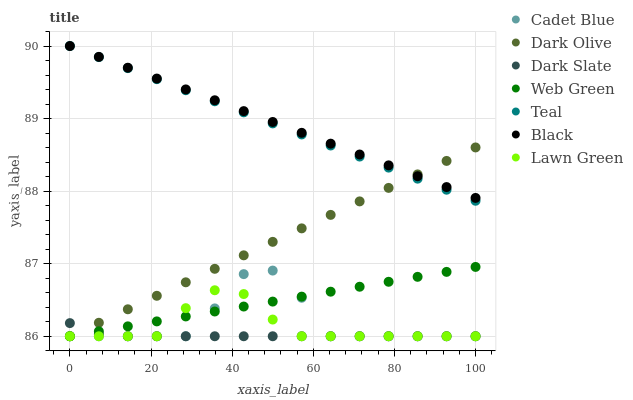Does Dark Slate have the minimum area under the curve?
Answer yes or no. Yes. Does Black have the maximum area under the curve?
Answer yes or no. Yes. Does Cadet Blue have the minimum area under the curve?
Answer yes or no. No. Does Cadet Blue have the maximum area under the curve?
Answer yes or no. No. Is Teal the smoothest?
Answer yes or no. Yes. Is Cadet Blue the roughest?
Answer yes or no. Yes. Is Dark Olive the smoothest?
Answer yes or no. No. Is Dark Olive the roughest?
Answer yes or no. No. Does Lawn Green have the lowest value?
Answer yes or no. Yes. Does Black have the lowest value?
Answer yes or no. No. Does Teal have the highest value?
Answer yes or no. Yes. Does Cadet Blue have the highest value?
Answer yes or no. No. Is Cadet Blue less than Black?
Answer yes or no. Yes. Is Black greater than Web Green?
Answer yes or no. Yes. Does Web Green intersect Dark Slate?
Answer yes or no. Yes. Is Web Green less than Dark Slate?
Answer yes or no. No. Is Web Green greater than Dark Slate?
Answer yes or no. No. Does Cadet Blue intersect Black?
Answer yes or no. No. 